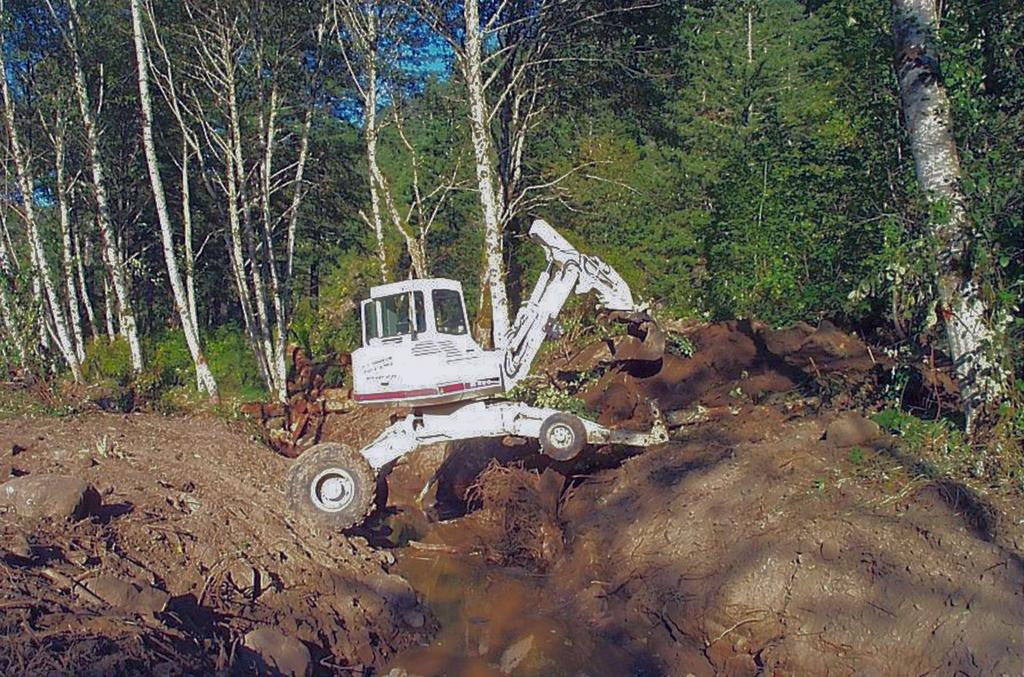What type of animal is in the image? There is a white crane in the image. What surface is the crane standing on? The crane is standing on mud. What else can be seen in the image besides the crane? There is water visible in the image. What is visible in the background of the image? There are trees in the background of the image. What type of shirt is the hen wearing in the image? There is no hen present in the image, and therefore no shirt can be observed. 